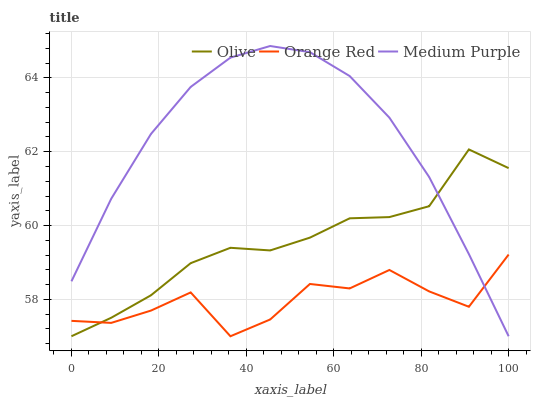Does Orange Red have the minimum area under the curve?
Answer yes or no. Yes. Does Medium Purple have the maximum area under the curve?
Answer yes or no. Yes. Does Medium Purple have the minimum area under the curve?
Answer yes or no. No. Does Orange Red have the maximum area under the curve?
Answer yes or no. No. Is Medium Purple the smoothest?
Answer yes or no. Yes. Is Orange Red the roughest?
Answer yes or no. Yes. Is Orange Red the smoothest?
Answer yes or no. No. Is Medium Purple the roughest?
Answer yes or no. No. Does Olive have the lowest value?
Answer yes or no. Yes. Does Medium Purple have the highest value?
Answer yes or no. Yes. Does Orange Red have the highest value?
Answer yes or no. No. Does Orange Red intersect Olive?
Answer yes or no. Yes. Is Orange Red less than Olive?
Answer yes or no. No. Is Orange Red greater than Olive?
Answer yes or no. No. 